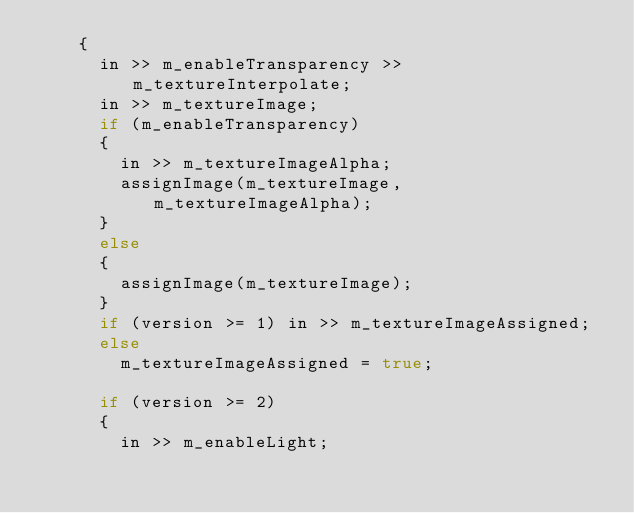Convert code to text. <code><loc_0><loc_0><loc_500><loc_500><_C++_>		{
			in >> m_enableTransparency >> m_textureInterpolate;
			in >> m_textureImage;
			if (m_enableTransparency)
			{
				in >> m_textureImageAlpha;
				assignImage(m_textureImage, m_textureImageAlpha);
			}
			else
			{
				assignImage(m_textureImage);
			}
			if (version >= 1) in >> m_textureImageAssigned;
			else
				m_textureImageAssigned = true;

			if (version >= 2)
			{
				in >> m_enableLight;</code> 